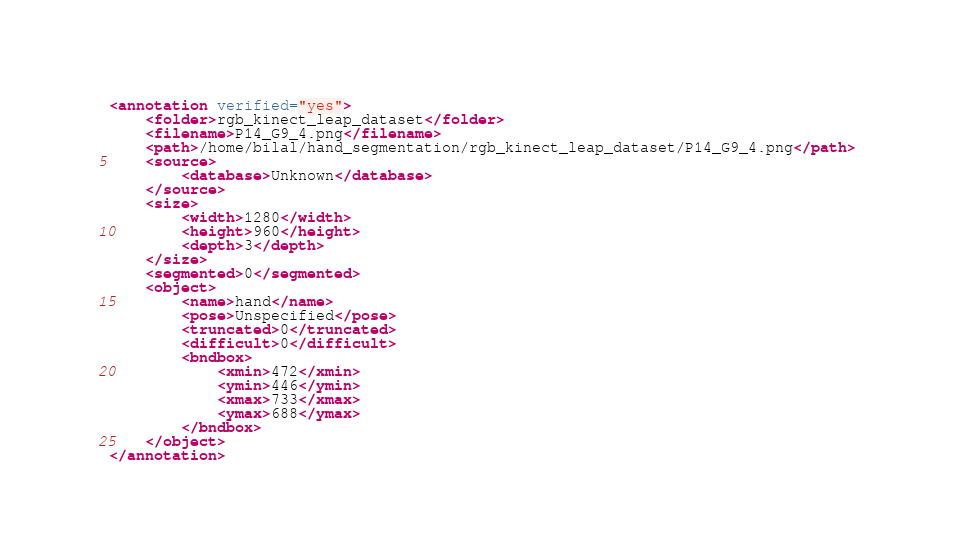<code> <loc_0><loc_0><loc_500><loc_500><_XML_><annotation verified="yes">
	<folder>rgb_kinect_leap_dataset</folder>
	<filename>P14_G9_4.png</filename>
	<path>/home/bilal/hand_segmentation/rgb_kinect_leap_dataset/P14_G9_4.png</path>
	<source>
		<database>Unknown</database>
	</source>
	<size>
		<width>1280</width>
		<height>960</height>
		<depth>3</depth>
	</size>
	<segmented>0</segmented>
	<object>
		<name>hand</name>
		<pose>Unspecified</pose>
		<truncated>0</truncated>
		<difficult>0</difficult>
		<bndbox>
			<xmin>472</xmin>
			<ymin>446</ymin>
			<xmax>733</xmax>
			<ymax>688</ymax>
		</bndbox>
	</object>
</annotation>
</code> 